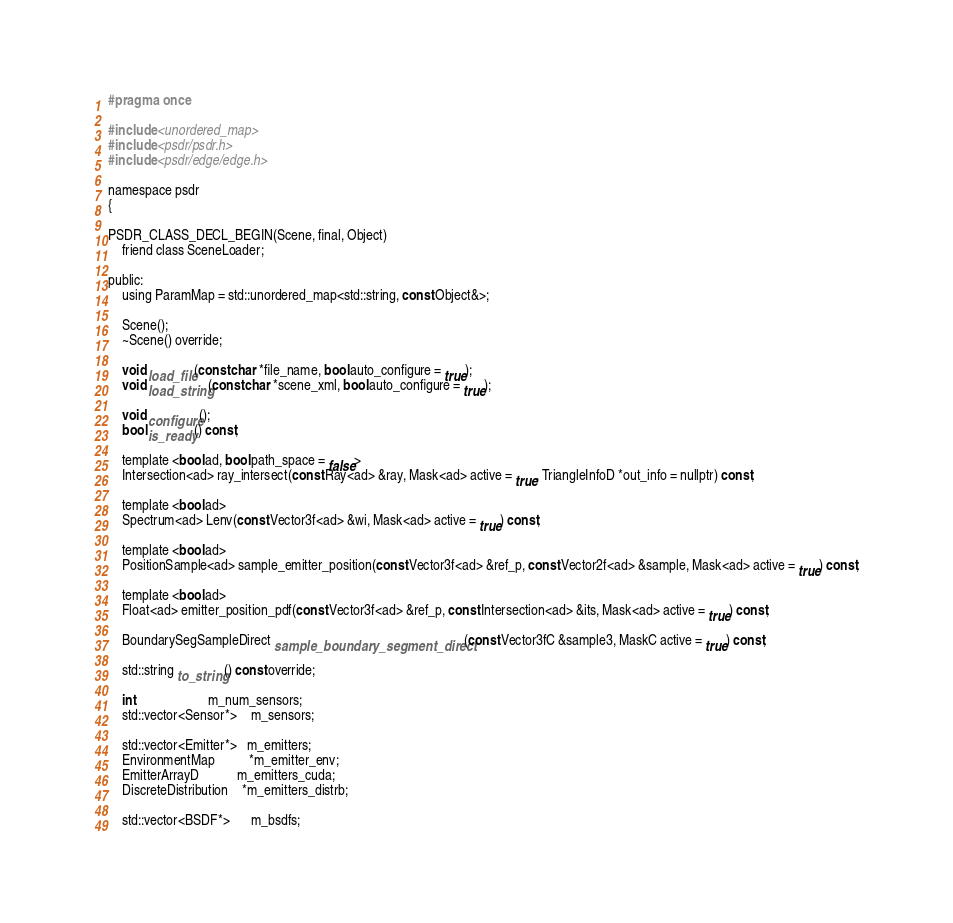<code> <loc_0><loc_0><loc_500><loc_500><_C_>#pragma once

#include <unordered_map>
#include <psdr/psdr.h>
#include <psdr/edge/edge.h>

namespace psdr
{

PSDR_CLASS_DECL_BEGIN(Scene, final, Object)
    friend class SceneLoader;

public:
    using ParamMap = std::unordered_map<std::string, const Object&>;

    Scene();
    ~Scene() override;

    void load_file(const char *file_name, bool auto_configure = true);
    void load_string(const char *scene_xml, bool auto_configure = true);

    void configure();
    bool is_ready() const;

    template <bool ad, bool path_space = false>
    Intersection<ad> ray_intersect(const Ray<ad> &ray, Mask<ad> active = true, TriangleInfoD *out_info = nullptr) const;

    template <bool ad>
    Spectrum<ad> Lenv(const Vector3f<ad> &wi, Mask<ad> active = true) const;

    template <bool ad>
    PositionSample<ad> sample_emitter_position(const Vector3f<ad> &ref_p, const Vector2f<ad> &sample, Mask<ad> active = true) const;

    template <bool ad>
    Float<ad> emitter_position_pdf(const Vector3f<ad> &ref_p, const Intersection<ad> &its, Mask<ad> active = true) const;

    BoundarySegSampleDirect sample_boundary_segment_direct(const Vector3fC &sample3, MaskC active = true) const;

    std::string to_string() const override;

    int                     m_num_sensors;
    std::vector<Sensor*>    m_sensors;

    std::vector<Emitter*>   m_emitters;
    EnvironmentMap          *m_emitter_env;
    EmitterArrayD           m_emitters_cuda;
    DiscreteDistribution    *m_emitters_distrb;

    std::vector<BSDF*>      m_bsdfs;
</code> 